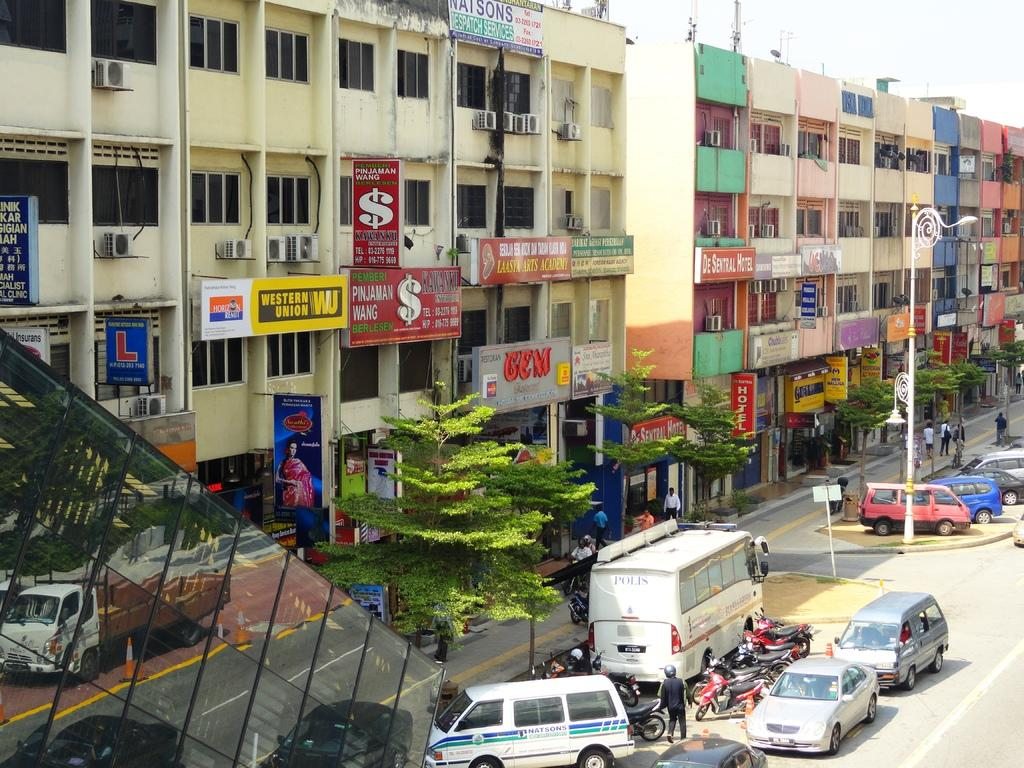What type of structures can be seen in the image? There are buildings in the image. What can be found on the buildings in the image? Name boards are visible on the buildings in the image. What type of cooling system is present in the image? Air conditioners are visible in the image. What type of lighting is present in the image? There is a street light in the image. What type of transportation is present in the image? Vehicles are present in the image. What type of surface can be seen in the image? There is a road in the image. What type of vegetation is visible in the image? Trees are visible in the image. What part of the natural environment is visible in the image? The sky is visible in the image. What type of polish is being applied to the vehicles in the image? There is no indication of any polishing activity in the image; vehicles are simply present. Where is the lunchroom located in the image? There is no mention of a lunchroom in the image; it features buildings, name boards, air conditioners, street lights, vehicles, a road, trees, and the sky. 